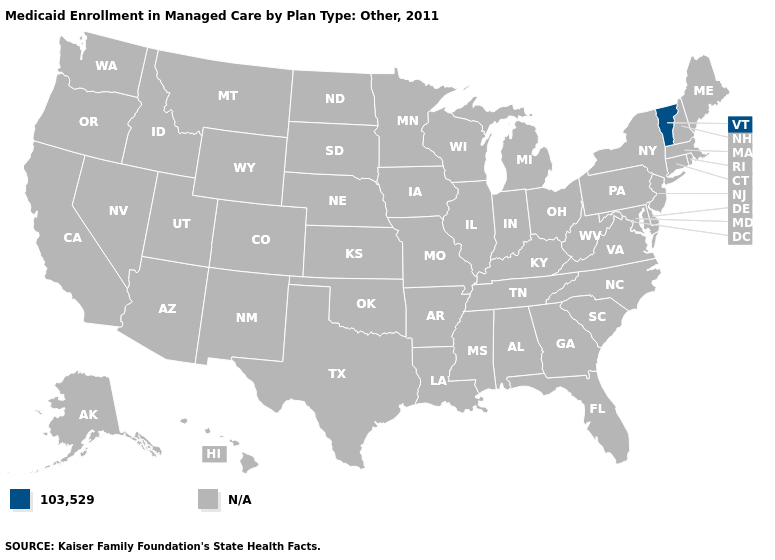What is the value of Utah?
Be succinct. N/A. Is the legend a continuous bar?
Concise answer only. No. Name the states that have a value in the range 103,529?
Short answer required. Vermont. What is the lowest value in the USA?
Quick response, please. 103,529. What is the value of Idaho?
Short answer required. N/A. What is the value of Connecticut?
Be succinct. N/A. How many symbols are there in the legend?
Be succinct. 2. What is the lowest value in the Northeast?
Answer briefly. 103,529. Name the states that have a value in the range 103,529?
Keep it brief. Vermont. 